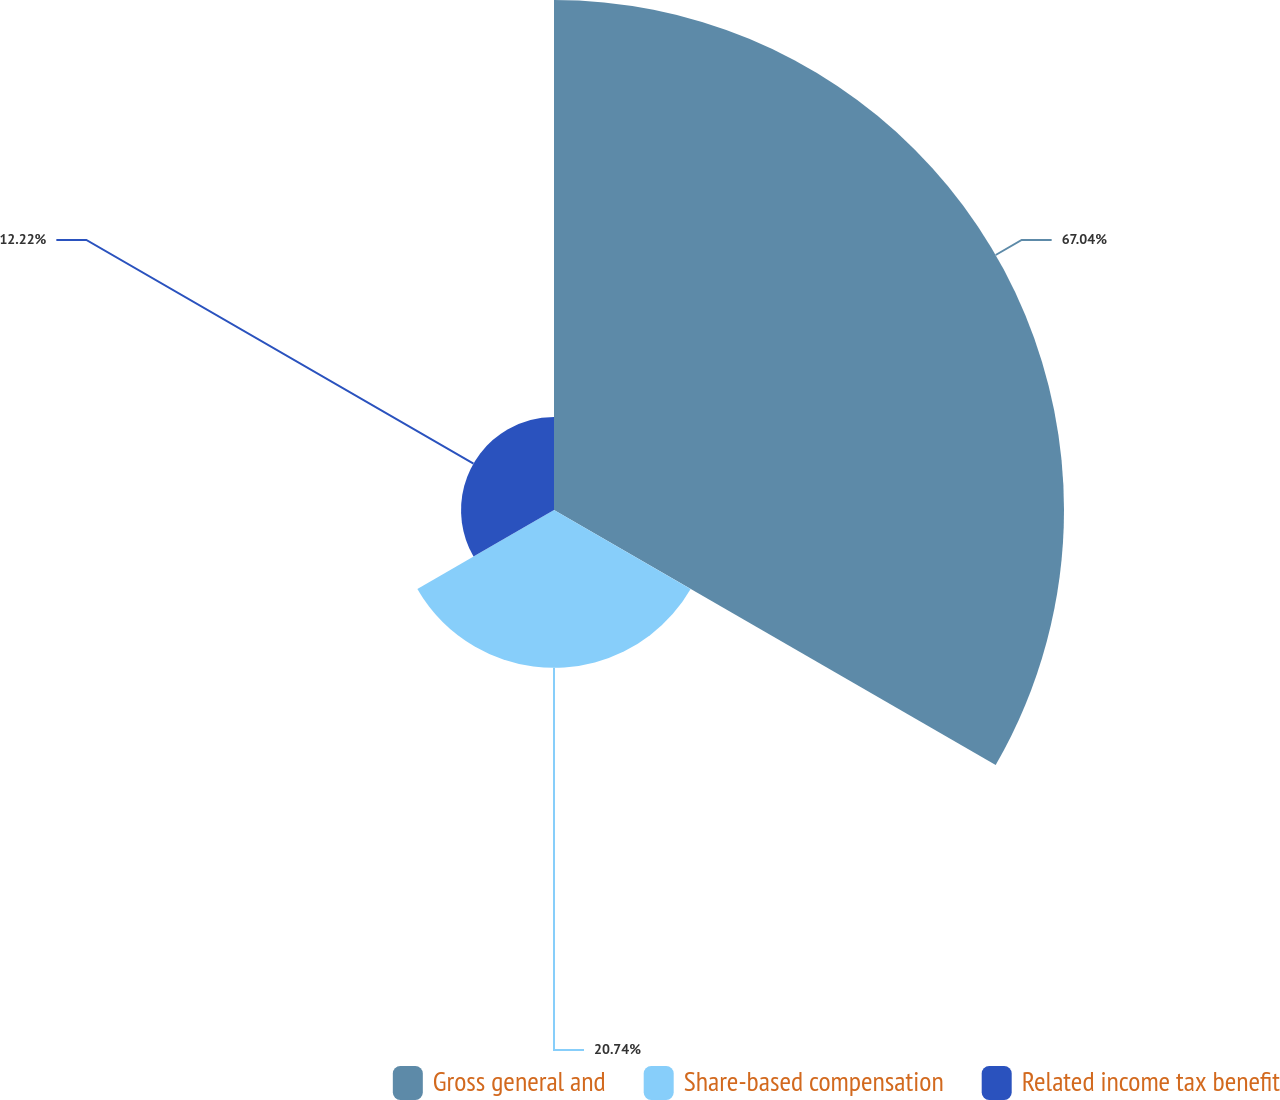Convert chart to OTSL. <chart><loc_0><loc_0><loc_500><loc_500><pie_chart><fcel>Gross general and<fcel>Share-based compensation<fcel>Related income tax benefit<nl><fcel>67.04%<fcel>20.74%<fcel>12.22%<nl></chart> 